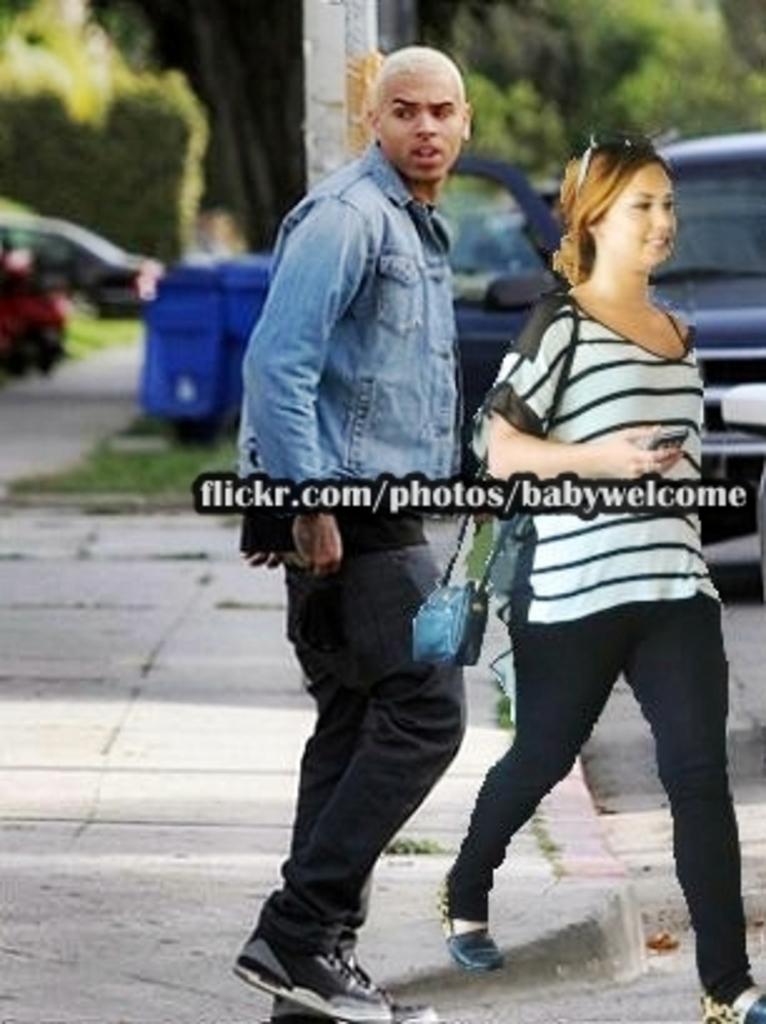Is this photo from flicker?
Provide a succinct answer. Yes. Where was this photo posted originally?
Make the answer very short. Flickr.com/photos/babywelcome. 